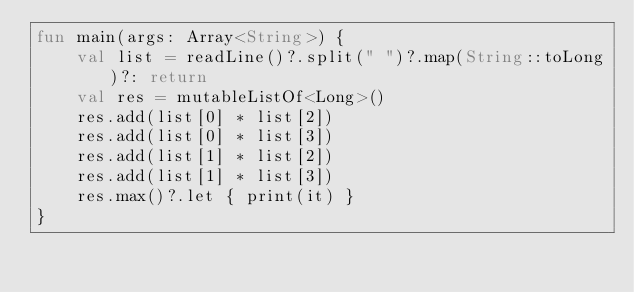Convert code to text. <code><loc_0><loc_0><loc_500><loc_500><_Kotlin_>fun main(args: Array<String>) {
    val list = readLine()?.split(" ")?.map(String::toLong)?: return
    val res = mutableListOf<Long>()
    res.add(list[0] * list[2])
    res.add(list[0] * list[3])
    res.add(list[1] * list[2])
    res.add(list[1] * list[3])
    res.max()?.let { print(it) }
}
</code> 